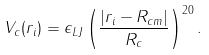<formula> <loc_0><loc_0><loc_500><loc_500>V _ { c } ( r _ { i } ) = \epsilon _ { L J } \left ( \frac { | r _ { i } - R _ { c m } | } { R _ { c } } \right ) ^ { 2 0 } .</formula> 